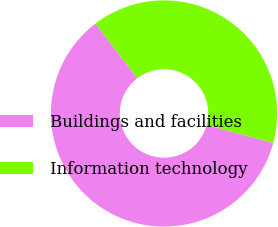Convert chart. <chart><loc_0><loc_0><loc_500><loc_500><pie_chart><fcel>Buildings and facilities<fcel>Information technology<nl><fcel>60.44%<fcel>39.56%<nl></chart> 